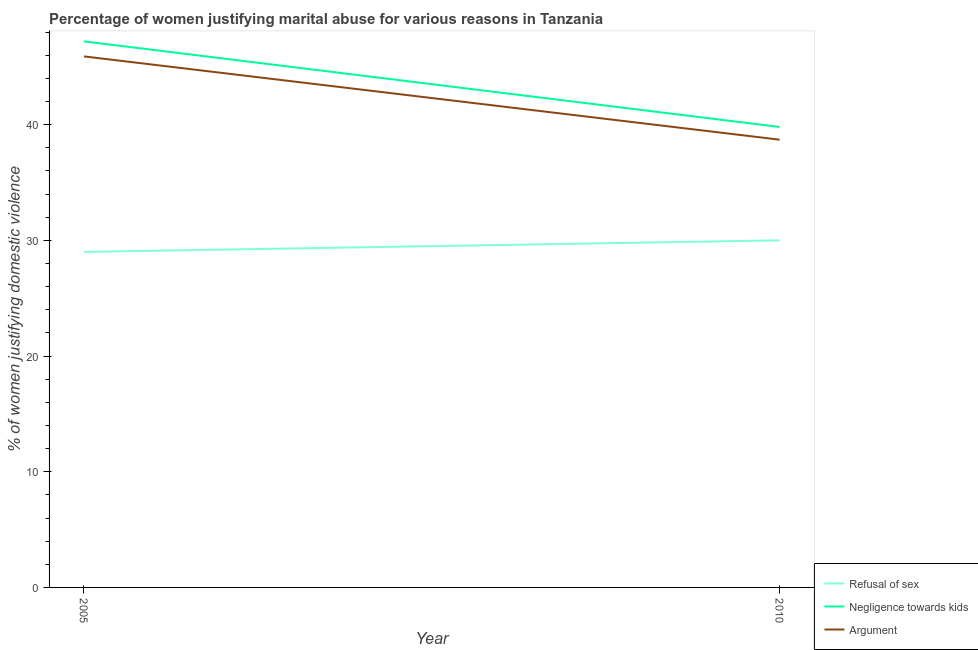How many different coloured lines are there?
Make the answer very short. 3. Is the number of lines equal to the number of legend labels?
Your answer should be compact. Yes. What is the percentage of women justifying domestic violence due to negligence towards kids in 2005?
Give a very brief answer. 47.2. Across all years, what is the maximum percentage of women justifying domestic violence due to arguments?
Your answer should be very brief. 45.9. Across all years, what is the minimum percentage of women justifying domestic violence due to refusal of sex?
Offer a terse response. 29. What is the total percentage of women justifying domestic violence due to refusal of sex in the graph?
Your answer should be very brief. 59. What is the difference between the percentage of women justifying domestic violence due to refusal of sex in 2005 and that in 2010?
Your answer should be very brief. -1. What is the difference between the percentage of women justifying domestic violence due to refusal of sex in 2010 and the percentage of women justifying domestic violence due to negligence towards kids in 2005?
Your answer should be very brief. -17.2. What is the average percentage of women justifying domestic violence due to arguments per year?
Offer a terse response. 42.3. What is the ratio of the percentage of women justifying domestic violence due to arguments in 2005 to that in 2010?
Make the answer very short. 1.19. Is the percentage of women justifying domestic violence due to refusal of sex in 2005 less than that in 2010?
Offer a very short reply. Yes. In how many years, is the percentage of women justifying domestic violence due to negligence towards kids greater than the average percentage of women justifying domestic violence due to negligence towards kids taken over all years?
Offer a very short reply. 1. Is the percentage of women justifying domestic violence due to arguments strictly greater than the percentage of women justifying domestic violence due to negligence towards kids over the years?
Provide a succinct answer. No. What is the difference between two consecutive major ticks on the Y-axis?
Make the answer very short. 10. Does the graph contain any zero values?
Provide a succinct answer. No. Does the graph contain grids?
Keep it short and to the point. No. How many legend labels are there?
Your response must be concise. 3. How are the legend labels stacked?
Offer a very short reply. Vertical. What is the title of the graph?
Offer a very short reply. Percentage of women justifying marital abuse for various reasons in Tanzania. Does "Consumption Tax" appear as one of the legend labels in the graph?
Make the answer very short. No. What is the label or title of the X-axis?
Ensure brevity in your answer.  Year. What is the label or title of the Y-axis?
Provide a succinct answer. % of women justifying domestic violence. What is the % of women justifying domestic violence of Negligence towards kids in 2005?
Provide a succinct answer. 47.2. What is the % of women justifying domestic violence of Argument in 2005?
Make the answer very short. 45.9. What is the % of women justifying domestic violence in Negligence towards kids in 2010?
Offer a terse response. 39.8. What is the % of women justifying domestic violence of Argument in 2010?
Your answer should be very brief. 38.7. Across all years, what is the maximum % of women justifying domestic violence in Negligence towards kids?
Keep it short and to the point. 47.2. Across all years, what is the maximum % of women justifying domestic violence of Argument?
Make the answer very short. 45.9. Across all years, what is the minimum % of women justifying domestic violence in Negligence towards kids?
Provide a succinct answer. 39.8. Across all years, what is the minimum % of women justifying domestic violence of Argument?
Provide a short and direct response. 38.7. What is the total % of women justifying domestic violence in Refusal of sex in the graph?
Your answer should be very brief. 59. What is the total % of women justifying domestic violence in Argument in the graph?
Provide a succinct answer. 84.6. What is the difference between the % of women justifying domestic violence in Refusal of sex in 2005 and the % of women justifying domestic violence in Negligence towards kids in 2010?
Your answer should be compact. -10.8. What is the difference between the % of women justifying domestic violence of Negligence towards kids in 2005 and the % of women justifying domestic violence of Argument in 2010?
Provide a succinct answer. 8.5. What is the average % of women justifying domestic violence of Refusal of sex per year?
Your response must be concise. 29.5. What is the average % of women justifying domestic violence in Negligence towards kids per year?
Your answer should be compact. 43.5. What is the average % of women justifying domestic violence of Argument per year?
Your answer should be very brief. 42.3. In the year 2005, what is the difference between the % of women justifying domestic violence in Refusal of sex and % of women justifying domestic violence in Negligence towards kids?
Your answer should be compact. -18.2. In the year 2005, what is the difference between the % of women justifying domestic violence of Refusal of sex and % of women justifying domestic violence of Argument?
Make the answer very short. -16.9. In the year 2005, what is the difference between the % of women justifying domestic violence in Negligence towards kids and % of women justifying domestic violence in Argument?
Provide a succinct answer. 1.3. In the year 2010, what is the difference between the % of women justifying domestic violence of Refusal of sex and % of women justifying domestic violence of Argument?
Ensure brevity in your answer.  -8.7. What is the ratio of the % of women justifying domestic violence of Refusal of sex in 2005 to that in 2010?
Give a very brief answer. 0.97. What is the ratio of the % of women justifying domestic violence of Negligence towards kids in 2005 to that in 2010?
Your response must be concise. 1.19. What is the ratio of the % of women justifying domestic violence of Argument in 2005 to that in 2010?
Give a very brief answer. 1.19. What is the difference between the highest and the second highest % of women justifying domestic violence in Negligence towards kids?
Offer a very short reply. 7.4. What is the difference between the highest and the lowest % of women justifying domestic violence of Refusal of sex?
Give a very brief answer. 1. 